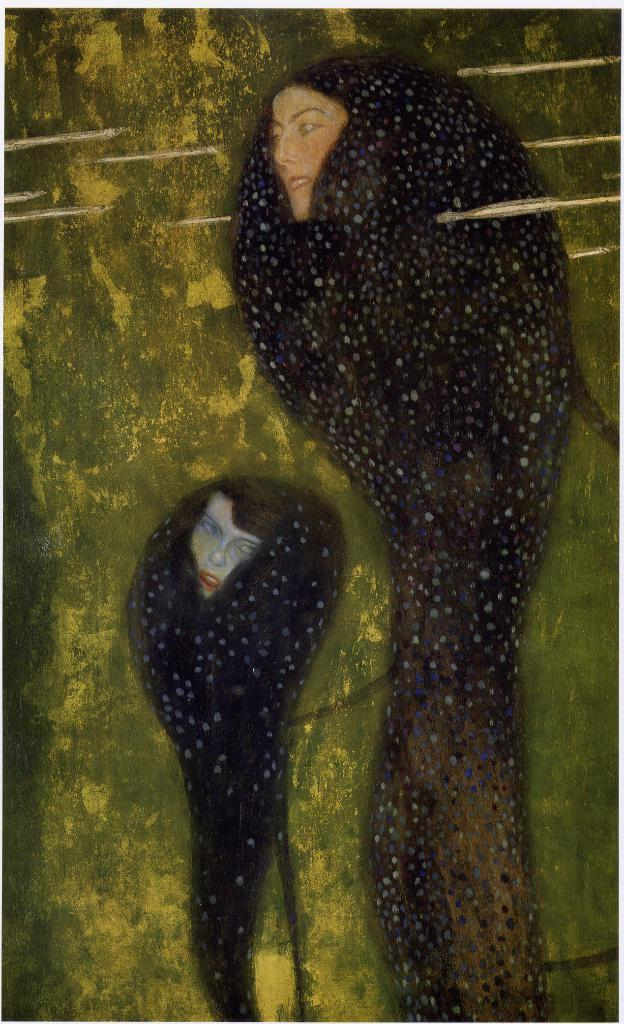What is the main subject of the image? There is a painting in the image. What does the painting depict? The painting depicts a person. Where is the painting located? The painting is on a wall. What type of sail can be seen in the painting? There is no sail present in the painting, as it depicts a person and not a sailing scene. 